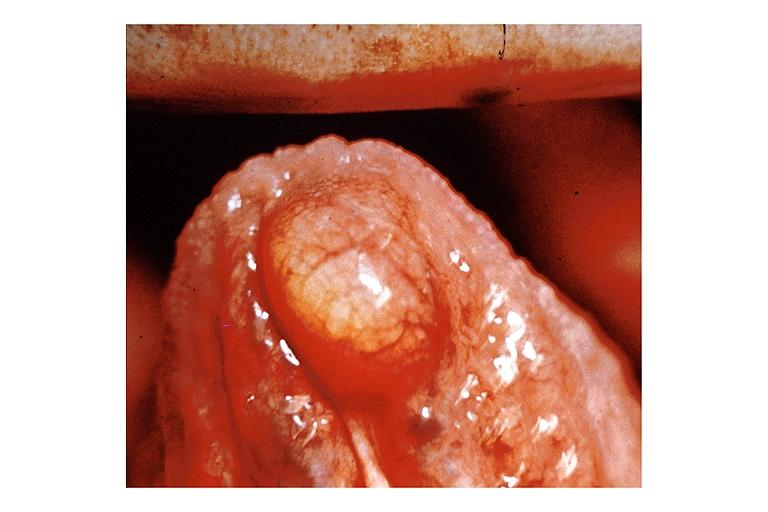does this image show lipoma?
Answer the question using a single word or phrase. Yes 